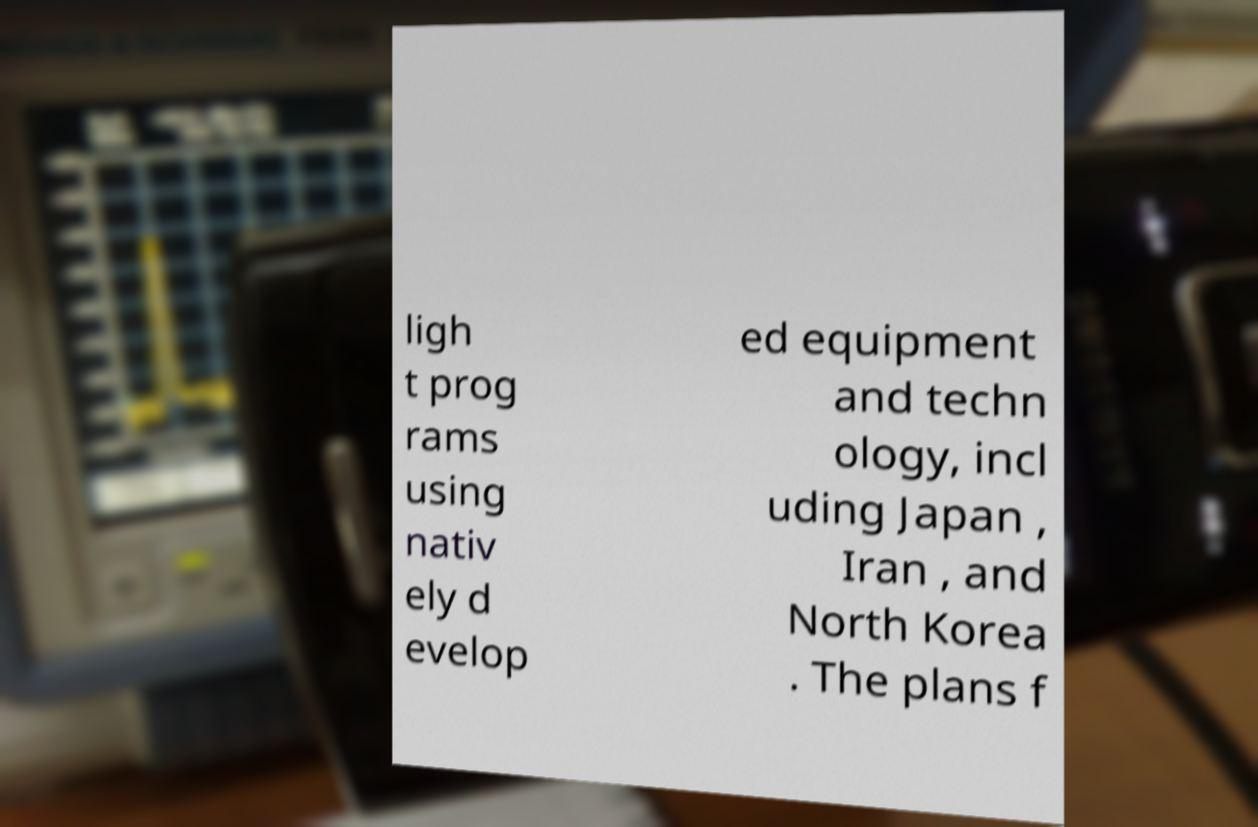For documentation purposes, I need the text within this image transcribed. Could you provide that? ligh t prog rams using nativ ely d evelop ed equipment and techn ology, incl uding Japan , Iran , and North Korea . The plans f 